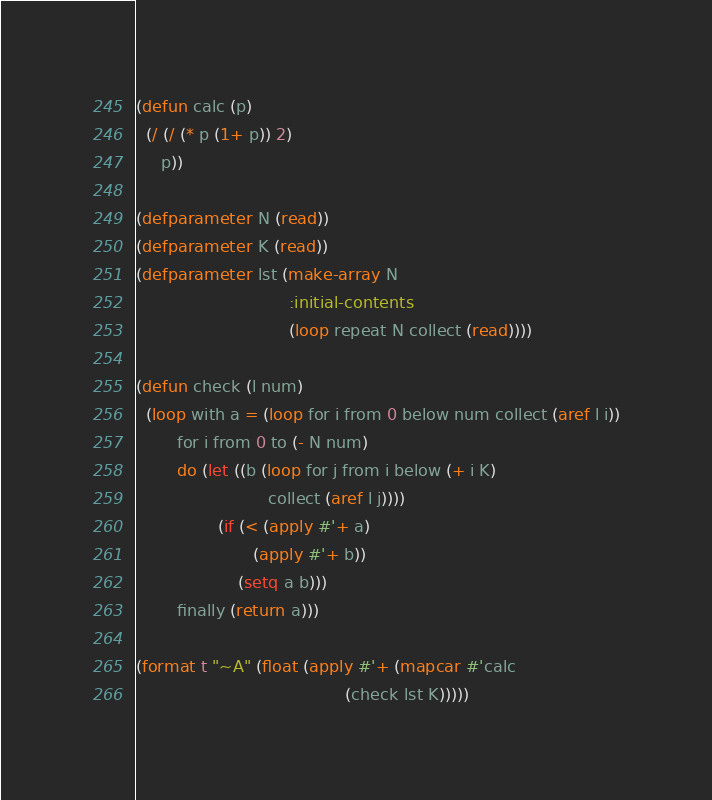<code> <loc_0><loc_0><loc_500><loc_500><_Lisp_>(defun calc (p)
  (/ (/ (* p (1+ p)) 2)
     p))

(defparameter N (read))
(defparameter K (read))
(defparameter lst (make-array N
                              :initial-contents 
                              (loop repeat N collect (read))))

(defun check (l num)
  (loop with a = (loop for i from 0 below num collect (aref l i))
        for i from 0 to (- N num)
        do (let ((b (loop for j from i below (+ i K)
                          collect (aref l j))))
                (if (< (apply #'+ a)
                       (apply #'+ b))
                    (setq a b)))
        finally (return a)))

(format t "~A" (float (apply #'+ (mapcar #'calc 
                                         (check lst K)))))
</code> 